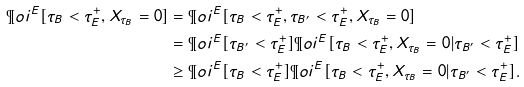<formula> <loc_0><loc_0><loc_500><loc_500>\P o i ^ { E } [ \tau _ { B } < \tau ^ { + } _ { E } , X _ { \tau _ { B } } = 0 ] & = \P o i ^ { E } [ \tau _ { B } < \tau ^ { + } _ { E } , \tau _ { B ^ { \prime } } < \tau ^ { + } _ { E } , X _ { \tau _ { B } } = 0 ] \\ & = \P o i ^ { E } [ \tau _ { B ^ { \prime } } < \tau ^ { + } _ { E } ] \P o i ^ { E } [ \tau _ { B } < \tau ^ { + } _ { E } , X _ { \tau _ { B } } = 0 | \tau _ { B ^ { \prime } } < \tau ^ { + } _ { E } ] \\ & \geq \P o i ^ { E } [ \tau _ { B } < \tau ^ { + } _ { E } ] \P o i ^ { E } [ \tau _ { B } < \tau ^ { + } _ { E } , X _ { \tau _ { B } } = 0 | \tau _ { B ^ { \prime } } < \tau ^ { + } _ { E } ] .</formula> 